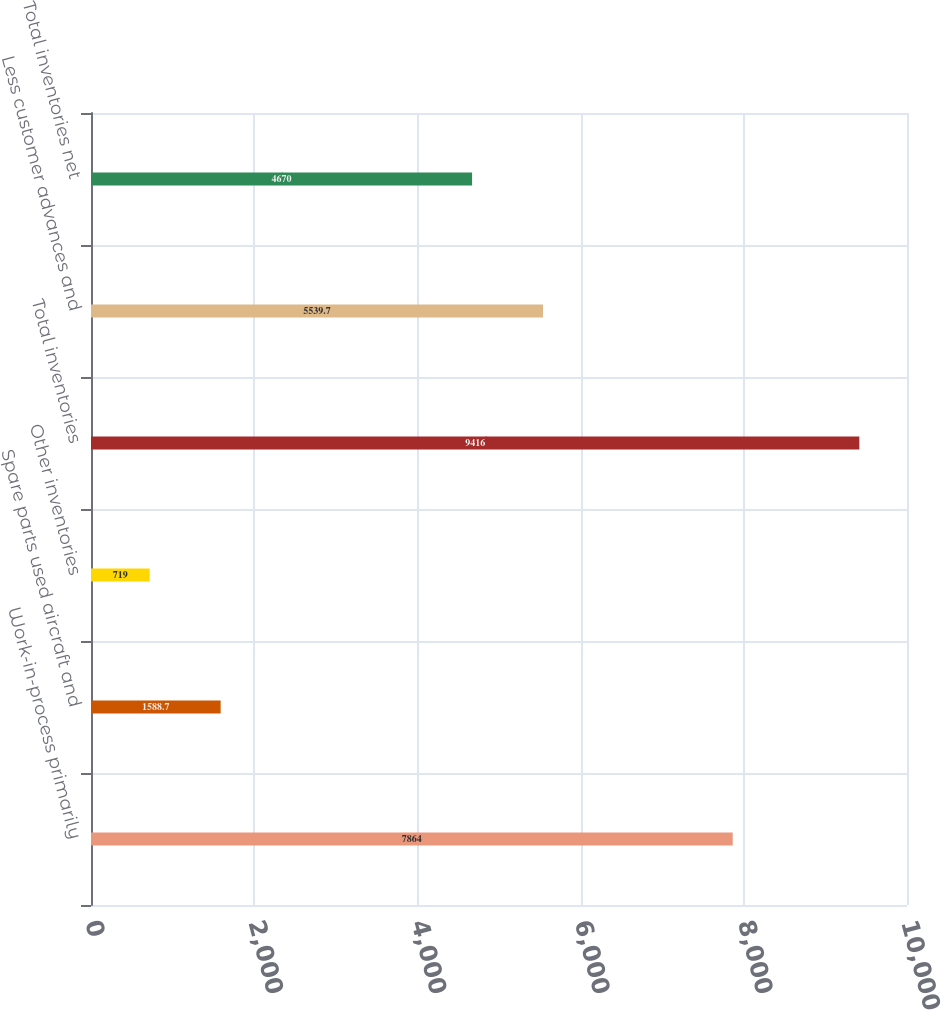<chart> <loc_0><loc_0><loc_500><loc_500><bar_chart><fcel>Work-in-process primarily<fcel>Spare parts used aircraft and<fcel>Other inventories<fcel>Total inventories<fcel>Less customer advances and<fcel>Total inventories net<nl><fcel>7864<fcel>1588.7<fcel>719<fcel>9416<fcel>5539.7<fcel>4670<nl></chart> 